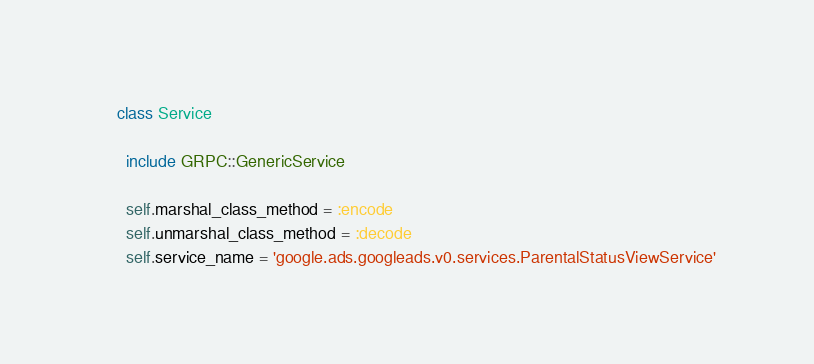<code> <loc_0><loc_0><loc_500><loc_500><_Ruby_>    class Service

      include GRPC::GenericService

      self.marshal_class_method = :encode
      self.unmarshal_class_method = :decode
      self.service_name = 'google.ads.googleads.v0.services.ParentalStatusViewService'
</code> 